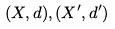Convert formula to latex. <formula><loc_0><loc_0><loc_500><loc_500>( X , d ) , ( X ^ { \prime } , d ^ { \prime } )</formula> 